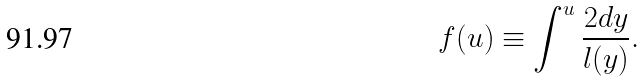Convert formula to latex. <formula><loc_0><loc_0><loc_500><loc_500>f ( u ) \equiv \int ^ { u } \frac { 2 d y } { l ( y ) } .</formula> 